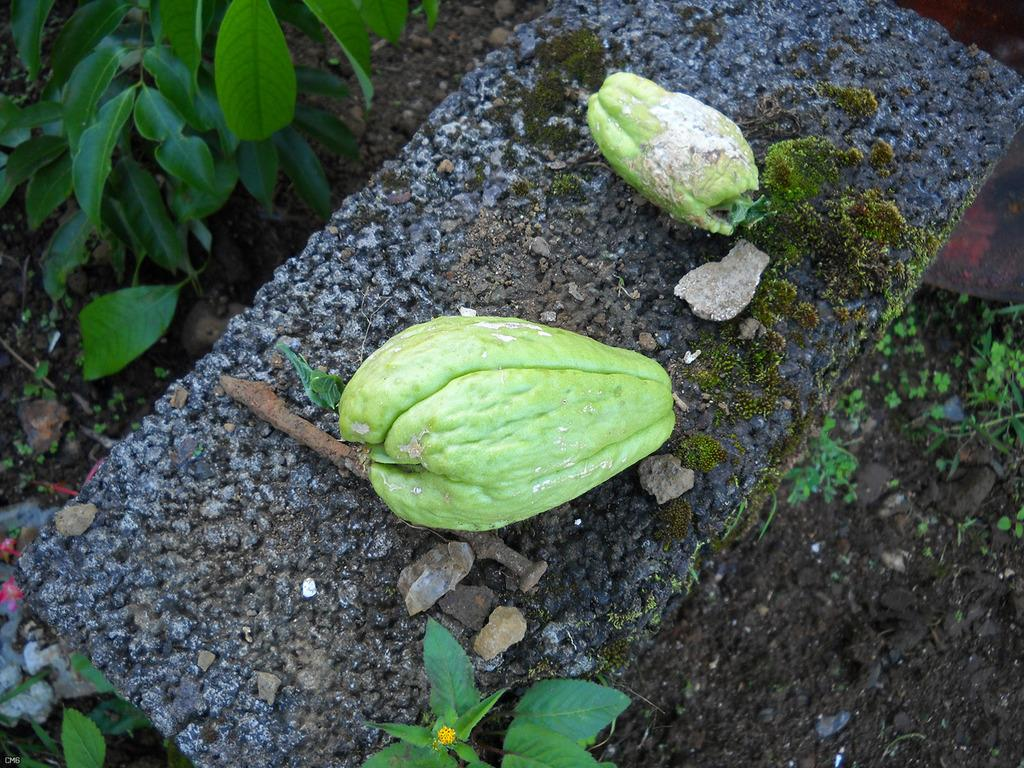What is placed on the stone in the image? There are fruits on a stone in the image. What else can be seen in the image besides the fruits? There are stones and plants in the image. What type of son can be seen playing with the fruits in the image? There is no son present in the image, and therefore no such activity can be observed. 